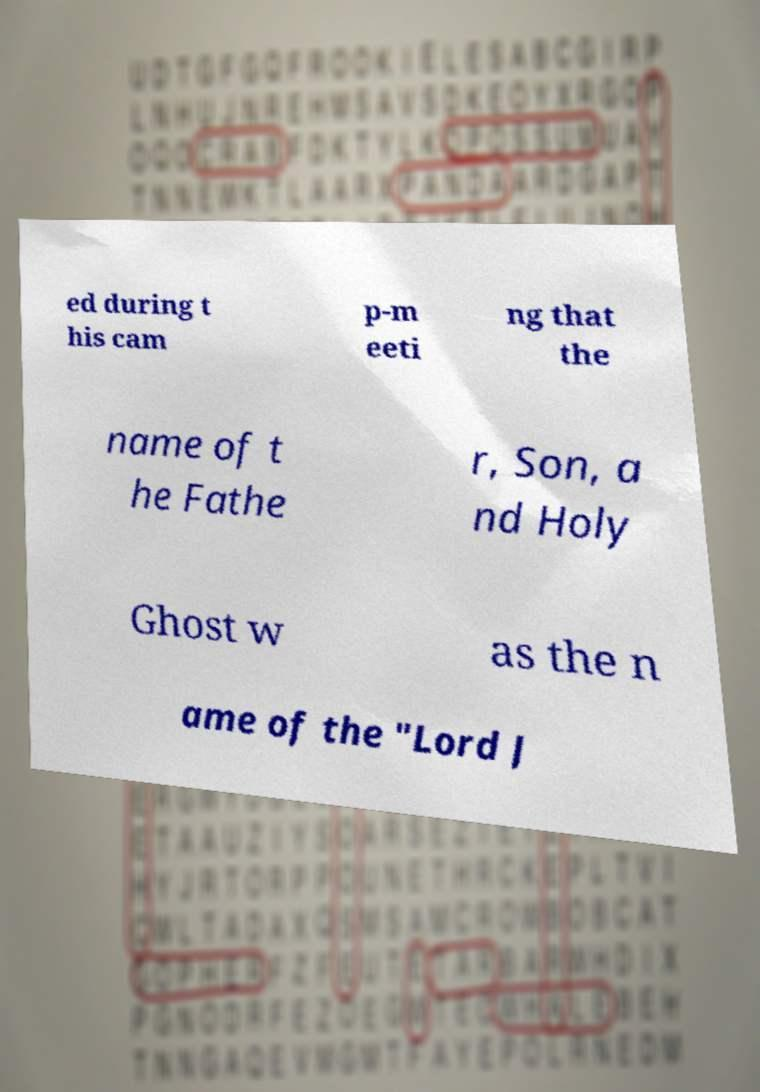Could you assist in decoding the text presented in this image and type it out clearly? ed during t his cam p-m eeti ng that the name of t he Fathe r, Son, a nd Holy Ghost w as the n ame of the "Lord J 